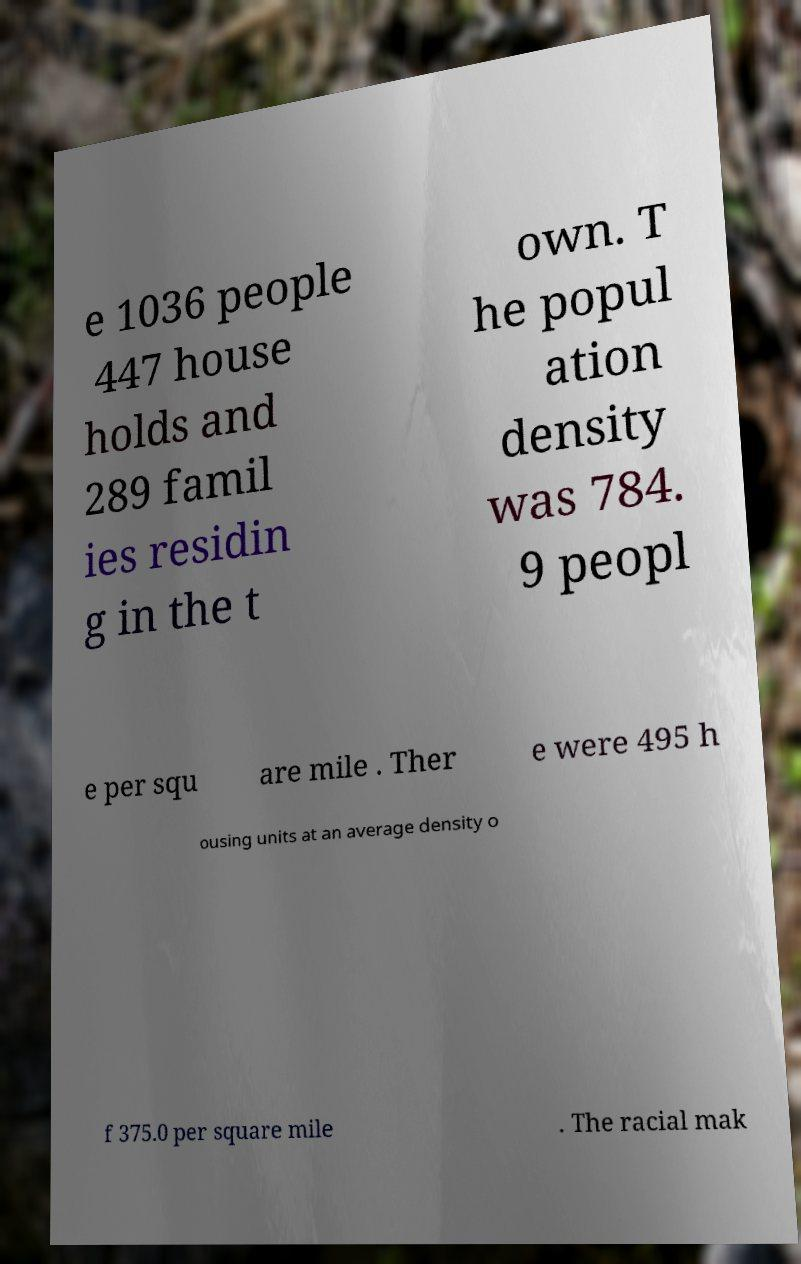Can you accurately transcribe the text from the provided image for me? e 1036 people 447 house holds and 289 famil ies residin g in the t own. T he popul ation density was 784. 9 peopl e per squ are mile . Ther e were 495 h ousing units at an average density o f 375.0 per square mile . The racial mak 